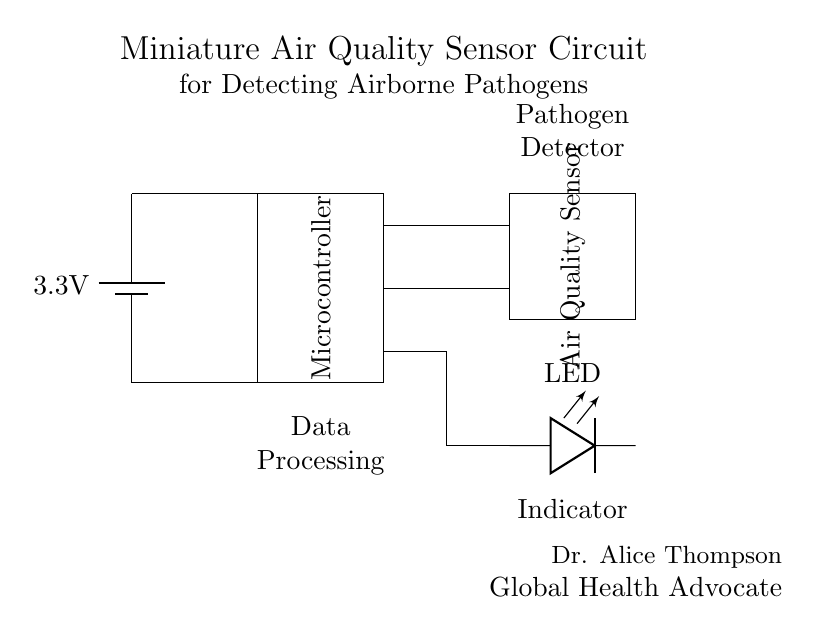What is the voltage of this circuit? The voltage supplied to the circuit is 3.3 volts, as indicated by the battery symbol at the top left of the diagram.
Answer: 3.3 volts What component processes the data in the circuit? The microcontroller, represented as a rectangle in the middle of the circuit, is responsible for data processing, acting on signals received from the air quality sensor.
Answer: Microcontroller What is the role of the LED in this circuit? The LED serves as an indicator, which provides visual feedback about the air quality status detected by the sensor, typically illuminating when there is a presence of airborne pathogens.
Answer: Indicator How many main components are there in this circuit? There are three main components: a battery, a microcontroller, and an air quality sensor. Counting these distinct elements gives a total of three separate components.
Answer: Three What type of sensor is used in this circuit? The circuit incorporates an air quality sensor, specifically designed to detect airborne pathogens and measure the quality of air.
Answer: Air quality sensor How are the microcontroller and air quality sensor connected? The microcontroller and the air quality sensor are connected via two horizontal lines that represent the electrical connections, allowing data transfer and communication between the two components.
Answer: Two lines 